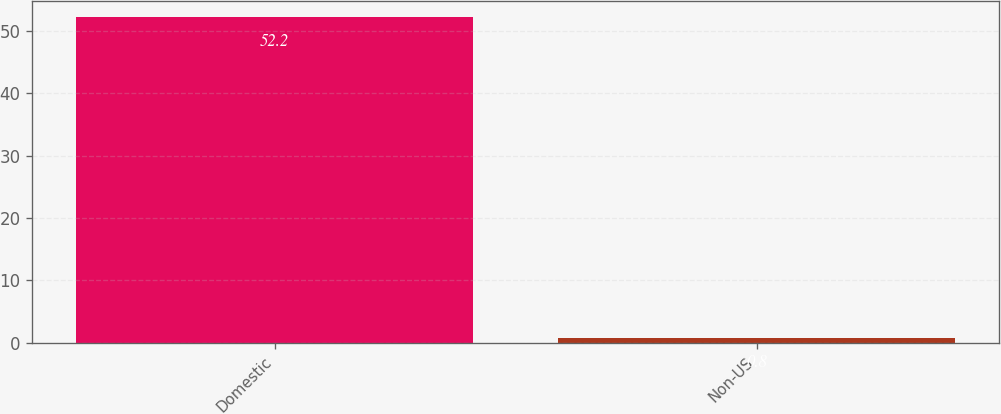Convert chart to OTSL. <chart><loc_0><loc_0><loc_500><loc_500><bar_chart><fcel>Domestic<fcel>Non-US<nl><fcel>52.2<fcel>0.8<nl></chart> 